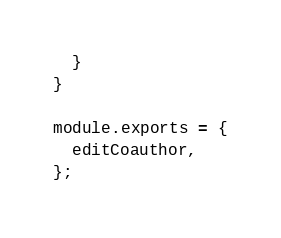<code> <loc_0><loc_0><loc_500><loc_500><_JavaScript_>  }
}

module.exports = {
  editCoauthor,
};
</code> 